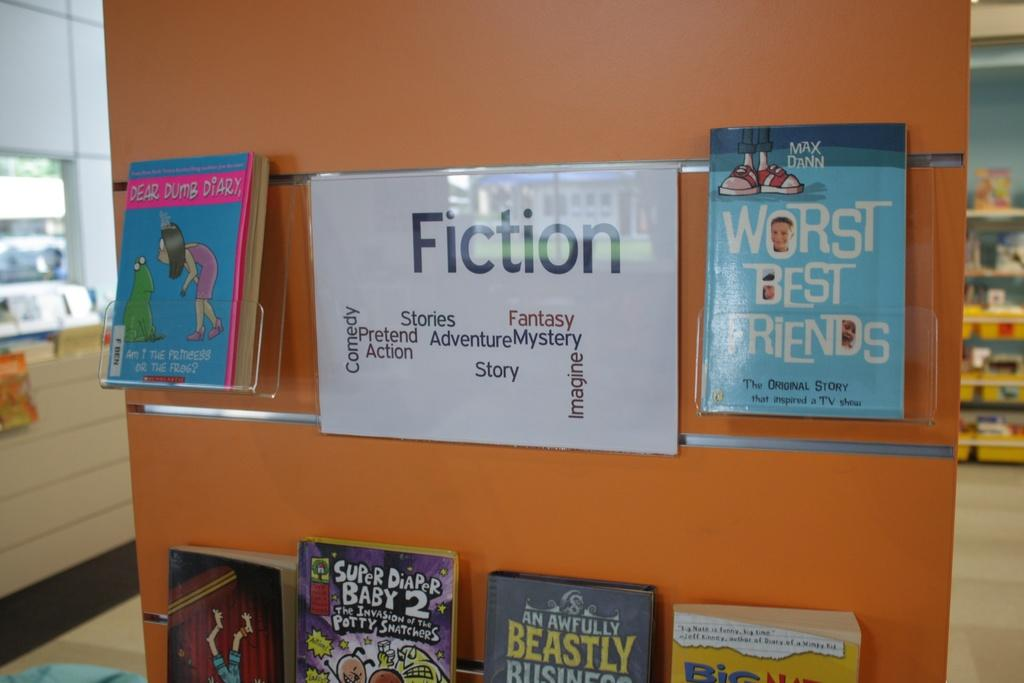<image>
Write a terse but informative summary of the picture. a white paper that has the word fiction on it 